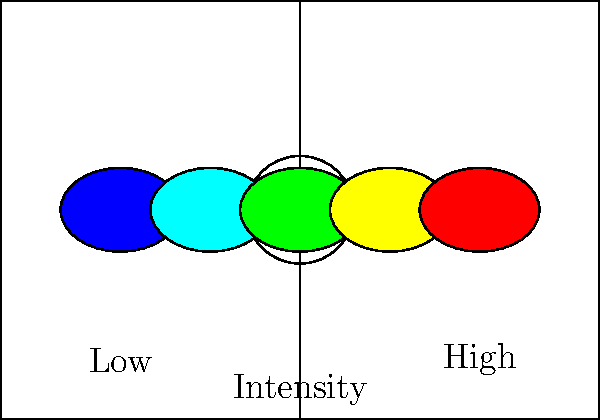Given the heat map representation of different running patterns on a soccer field, calculate the efficiency index ($E$) of a player's movement using the formula:

$$E = \frac{\sum_{i=1}^{n} I_i \cdot A_i}{\sum_{i=1}^{n} A_i}$$

where $I_i$ is the intensity level (1-5) and $A_i$ is the area covered by each intensity level. Assume the areas covered are 50, 60, 70, 55, and 45 square meters for intensities 1 through 5, respectively. Round your answer to two decimal places. To calculate the efficiency index, we'll follow these steps:

1. Identify the intensity levels and areas:
   - Intensity 1: 50 sq m
   - Intensity 2: 60 sq m
   - Intensity 3: 70 sq m
   - Intensity 4: 55 sq m
   - Intensity 5: 45 sq m

2. Calculate the numerator (sum of intensity * area):
   $$(1 \cdot 50) + (2 \cdot 60) + (3 \cdot 70) + (4 \cdot 55) + (5 \cdot 45) = 50 + 120 + 210 + 220 + 225 = 825$$

3. Calculate the denominator (sum of areas):
   $$50 + 60 + 70 + 55 + 45 = 280$$

4. Apply the formula:
   $$E = \frac{825}{280} = 2.9464285714$$

5. Round to two decimal places:
   $$E \approx 2.95$$
Answer: 2.95 